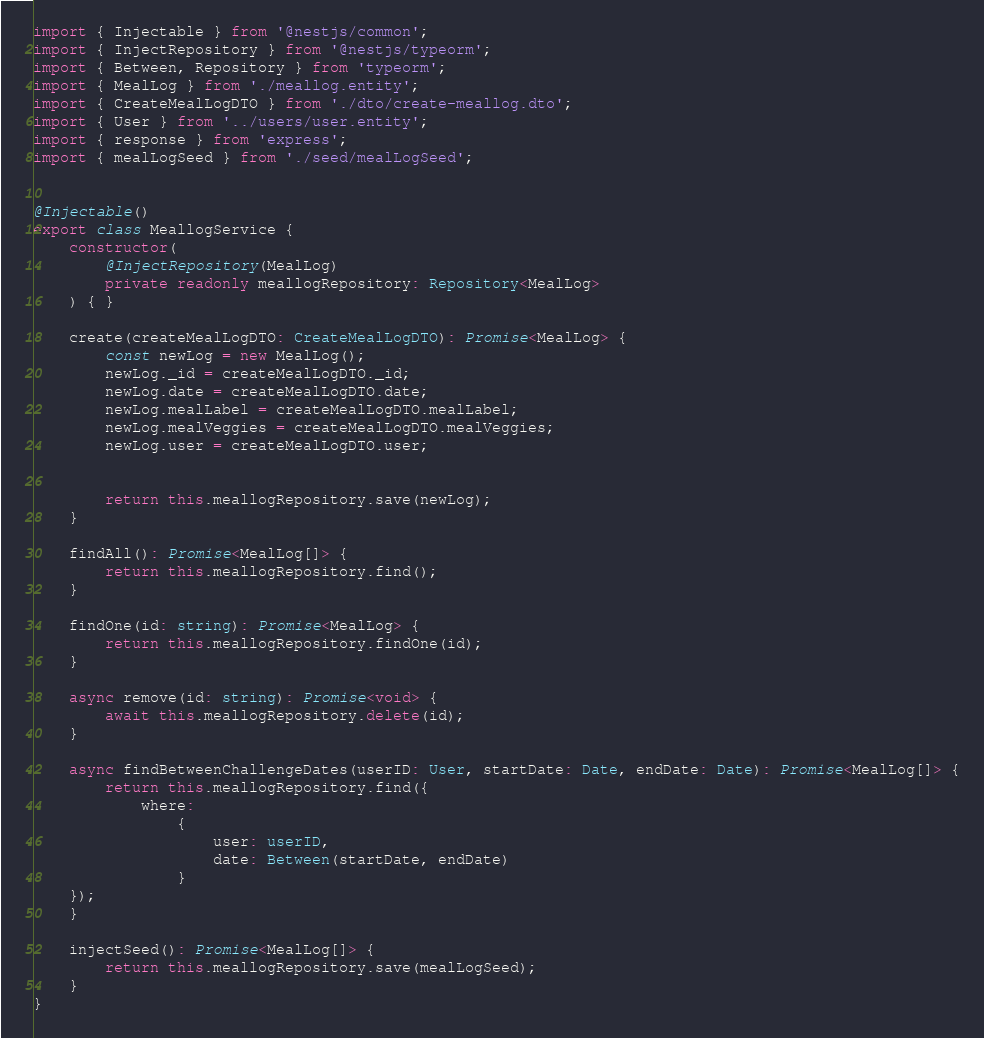Convert code to text. <code><loc_0><loc_0><loc_500><loc_500><_TypeScript_>import { Injectable } from '@nestjs/common';
import { InjectRepository } from '@nestjs/typeorm';
import { Between, Repository } from 'typeorm';
import { MealLog } from './meallog.entity';
import { CreateMealLogDTO } from './dto/create-meallog.dto';
import { User } from '../users/user.entity';
import { response } from 'express';
import { mealLogSeed } from './seed/mealLogSeed';


@Injectable()
export class MeallogService {
    constructor(
        @InjectRepository(MealLog)
        private readonly meallogRepository: Repository<MealLog>
    ) { }

    create(createMealLogDTO: CreateMealLogDTO): Promise<MealLog> {
        const newLog = new MealLog();
        newLog._id = createMealLogDTO._id;
        newLog.date = createMealLogDTO.date;
        newLog.mealLabel = createMealLogDTO.mealLabel;
        newLog.mealVeggies = createMealLogDTO.mealVeggies;
        newLog.user = createMealLogDTO.user;
        

        return this.meallogRepository.save(newLog);
    }

    findAll(): Promise<MealLog[]> {
        return this.meallogRepository.find();
    }

    findOne(id: string): Promise<MealLog> {
        return this.meallogRepository.findOne(id);
    }

    async remove(id: string): Promise<void> {
        await this.meallogRepository.delete(id);
    }

    async findBetweenChallengeDates(userID: User, startDate: Date, endDate: Date): Promise<MealLog[]> {
        return this.meallogRepository.find({
            where: 
                {
                    user: userID,
                    date: Between(startDate, endDate)
                }
    });
    }

    injectSeed(): Promise<MealLog[]> {
        return this.meallogRepository.save(mealLogSeed);
    }
}
</code> 